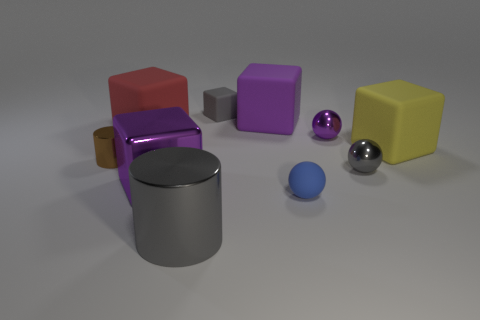Subtract all blue cylinders. How many purple cubes are left? 2 Subtract all yellow blocks. How many blocks are left? 4 Subtract all purple blocks. How many blocks are left? 3 Subtract 2 cubes. How many cubes are left? 3 Subtract all red cubes. Subtract all purple balls. How many cubes are left? 4 Subtract all cylinders. How many objects are left? 8 Add 3 big gray shiny cylinders. How many big gray shiny cylinders exist? 4 Subtract 0 green balls. How many objects are left? 10 Subtract all balls. Subtract all gray cylinders. How many objects are left? 6 Add 4 small brown metallic cylinders. How many small brown metallic cylinders are left? 5 